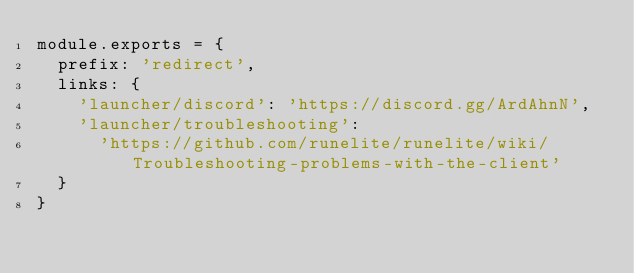Convert code to text. <code><loc_0><loc_0><loc_500><loc_500><_JavaScript_>module.exports = {
  prefix: 'redirect',
  links: {
    'launcher/discord': 'https://discord.gg/ArdAhnN',
    'launcher/troubleshooting':
      'https://github.com/runelite/runelite/wiki/Troubleshooting-problems-with-the-client'
  }
}
</code> 